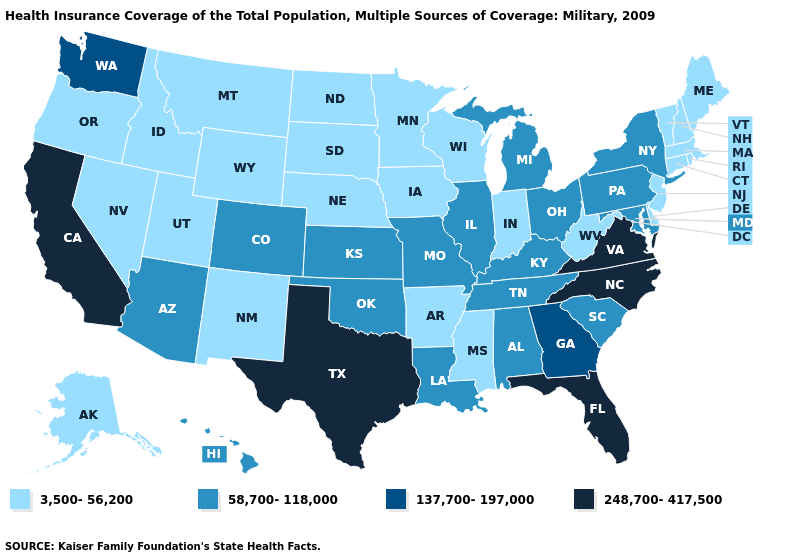Does Arkansas have a lower value than Connecticut?
Concise answer only. No. What is the value of Alabama?
Concise answer only. 58,700-118,000. Among the states that border Mississippi , which have the lowest value?
Give a very brief answer. Arkansas. What is the highest value in states that border Mississippi?
Answer briefly. 58,700-118,000. Name the states that have a value in the range 137,700-197,000?
Keep it brief. Georgia, Washington. Which states have the lowest value in the USA?
Quick response, please. Alaska, Arkansas, Connecticut, Delaware, Idaho, Indiana, Iowa, Maine, Massachusetts, Minnesota, Mississippi, Montana, Nebraska, Nevada, New Hampshire, New Jersey, New Mexico, North Dakota, Oregon, Rhode Island, South Dakota, Utah, Vermont, West Virginia, Wisconsin, Wyoming. What is the value of Montana?
Concise answer only. 3,500-56,200. What is the value of New York?
Keep it brief. 58,700-118,000. Does the first symbol in the legend represent the smallest category?
Give a very brief answer. Yes. Name the states that have a value in the range 137,700-197,000?
Answer briefly. Georgia, Washington. Among the states that border New Jersey , does Delaware have the highest value?
Answer briefly. No. Does Pennsylvania have the highest value in the Northeast?
Give a very brief answer. Yes. Which states hav the highest value in the West?
Answer briefly. California. What is the highest value in states that border Ohio?
Concise answer only. 58,700-118,000. Which states have the lowest value in the USA?
Keep it brief. Alaska, Arkansas, Connecticut, Delaware, Idaho, Indiana, Iowa, Maine, Massachusetts, Minnesota, Mississippi, Montana, Nebraska, Nevada, New Hampshire, New Jersey, New Mexico, North Dakota, Oregon, Rhode Island, South Dakota, Utah, Vermont, West Virginia, Wisconsin, Wyoming. 